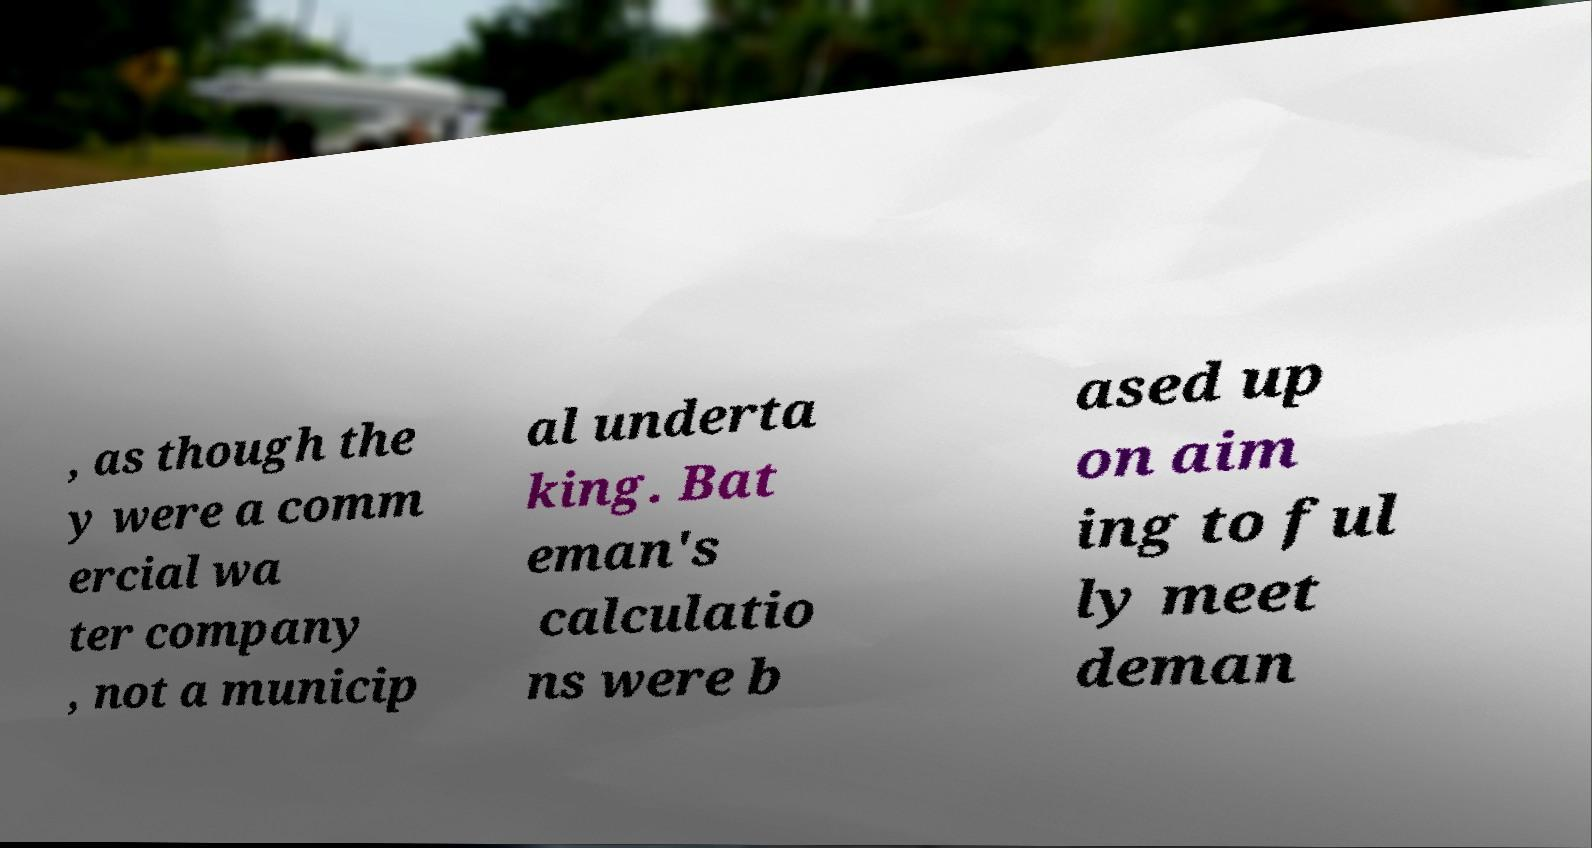Can you accurately transcribe the text from the provided image for me? , as though the y were a comm ercial wa ter company , not a municip al underta king. Bat eman's calculatio ns were b ased up on aim ing to ful ly meet deman 